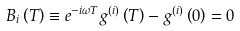<formula> <loc_0><loc_0><loc_500><loc_500>B _ { i } \left ( T \right ) \equiv e ^ { - i \omega T } g ^ { ( i ) } \left ( T \right ) - g ^ { ( i ) } \left ( 0 \right ) = 0</formula> 